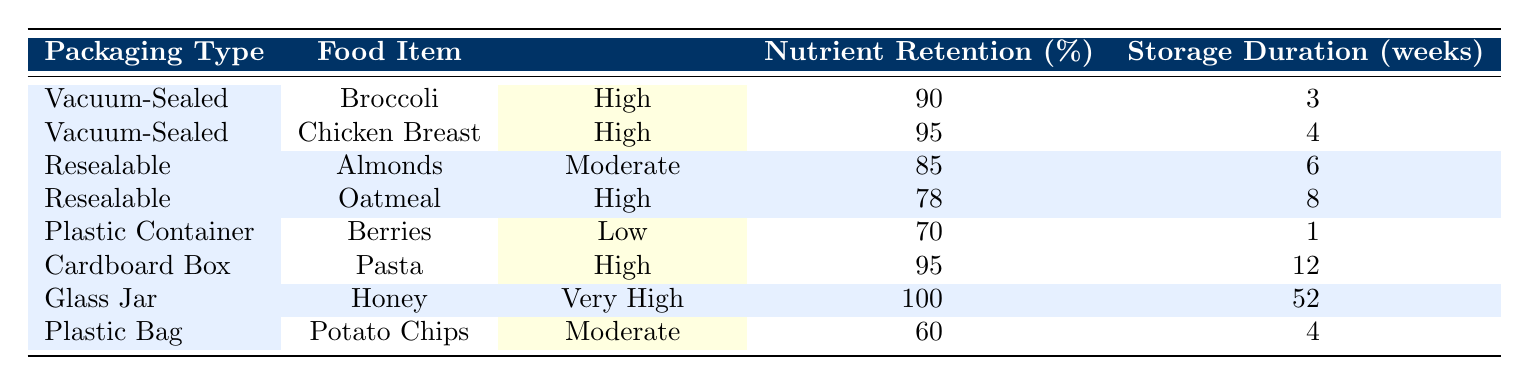What is the freshness level of Broccoli when vacuum-sealed? The table shows the row for Broccoli under the Vacuum-Sealed packaging type which indicates a freshness level of High.
Answer: High What is the nutrient retention percentage for Chicken Breast? Referring to the row for Chicken Breast under Vacuum-Sealed, it shows a nutrient retention percentage of 95.
Answer: 95 Is the freshness level of Pasta low? The table indicates that Pasta, packaged in a Cardboard Box, has a freshness level of High, so the answer is no.
Answer: No Which food item has the highest nutrient retention percentage, and what is that percentage? By examining each row, Honey in a Glass Jar has the highest nutrient retention percentage at 100.
Answer: 100 How many weeks can you store Oatmeal in a resealable package while maintaining its freshness level? The row for Oatmeal under Resealable packaging indicates a storage duration of 8 weeks while maintaining a high freshness level.
Answer: 8 What is the difference in nutrient retention between Potato Chips and Berries? The nutrient retention for Potato Chips is 60, and for Berries, it is 70. The difference is 70 - 60 = 10.
Answer: 10 On average, what is the nutrient retention percentage of food items packaged in resealable packaging? Sum the nutrient retention percentages of Almonds (85) and Oatmeal (78): 85 + 78 = 163. There are 2 items, so the average is 163 / 2 = 81.5.
Answer: 81.5 Does any packaging type preserve nutrients at 100 percent? Yes, the table lists Honey in a Glass Jar as having a nutrient retention percentage of 100.
Answer: Yes Which packaging type allows for the longest storage duration based on the table? Looking through the table, Honey in a Glass Jar can be stored for 52 weeks, the longest duration listed.
Answer: 52 weeks 